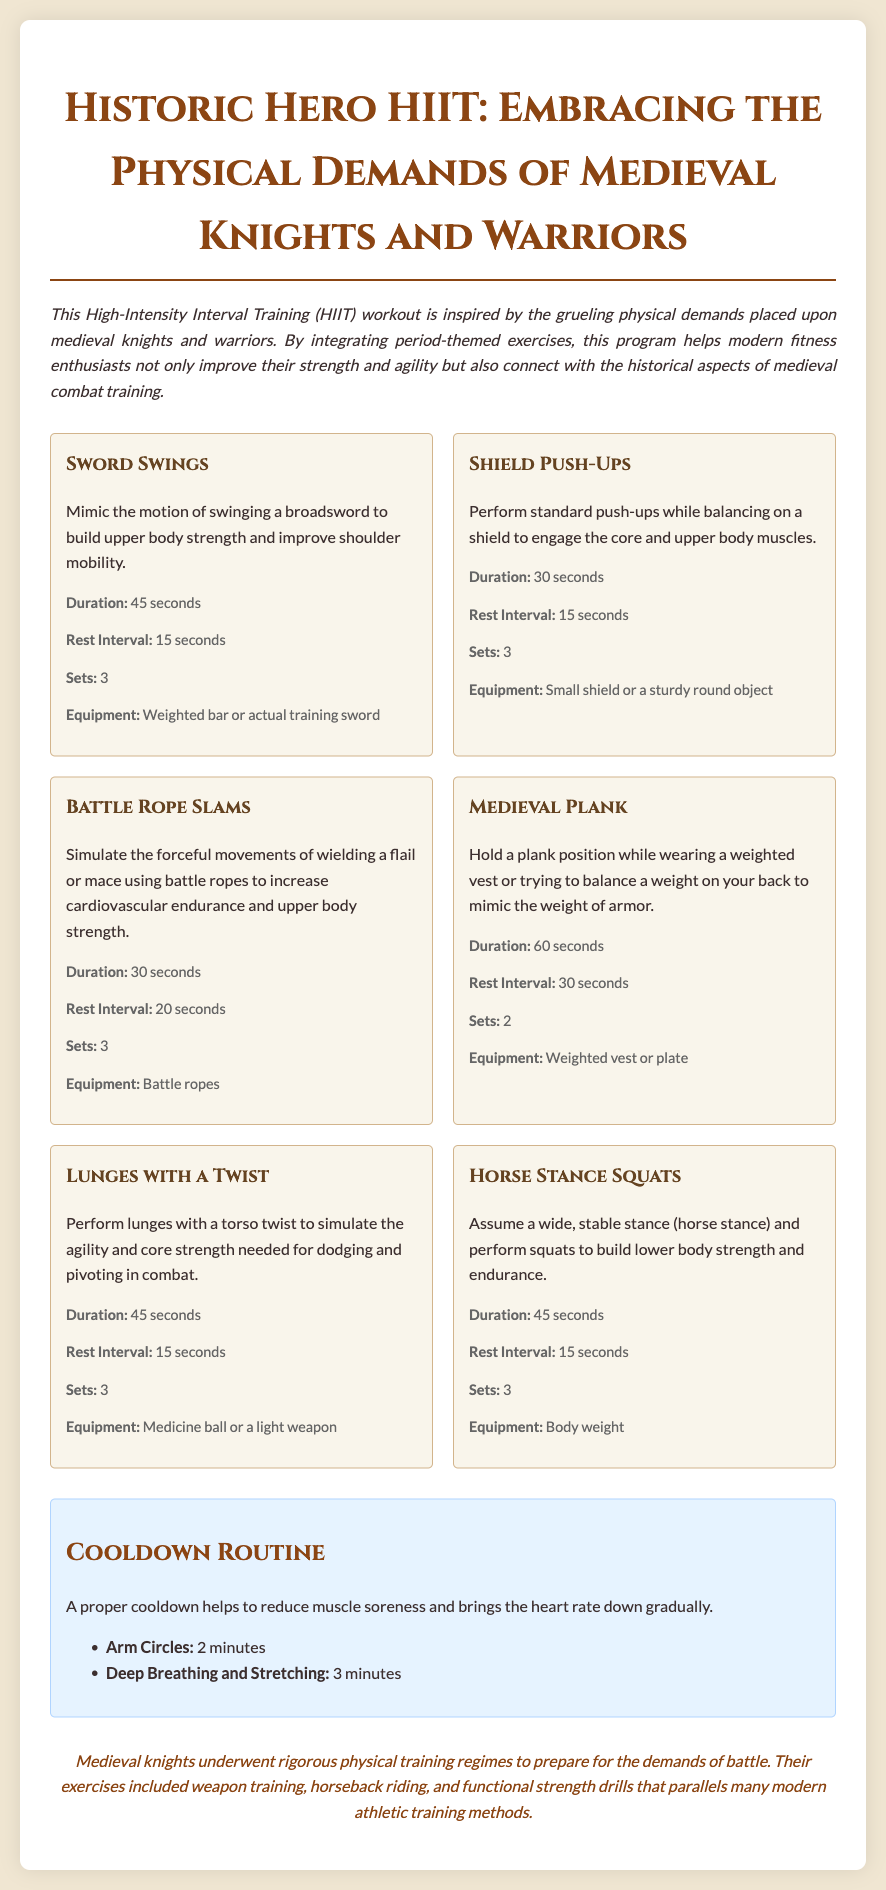What is the intended workout format of the plan? The document outlines a High-Intensity Interval Training (HIIT) workout plan, which involves alternating between periods of intense exercise and rest.
Answer: HIIT How long should the cooldown routine take? The cooldown routine includes specific time recommendations for exercises, totaling 5 minutes.
Answer: 5 minutes What exercise simulates the motion of swinging a sword? The document lists "Sword Swings" as the exercise that mimics this motion to build upper body strength.
Answer: Sword Swings How many sets of Battle Rope Slams are prescribed? The workout plan specifies the number of sets for each exercise, and for Battle Rope Slams, it is 3 sets.
Answer: 3 What equipment is needed for Shield Push-Ups? The document indicates that a small shield or a sturdy round object is recommended for this exercise.
Answer: Small shield or a sturdy round object What is the duration of the Medieval Plank exercise? The workout plan stipulates that the Medieval Plank should be held for 60 seconds.
Answer: 60 seconds Which exercise incorporates a torso twist? The "Lunges with a Twist" exercise includes torso twisting to enhance agility and core strength.
Answer: Lunges with a Twist How many seconds of rest are recommended after performing Horse Stance Squats? The rest interval after Horse Stance Squats is specified as 15 seconds in the document.
Answer: 15 seconds What historical aspect does the document connect to the workout? The document discusses the rigorous physical training regimes of medieval knights and warriors and parallels it with modern athletic training methods.
Answer: Physical training regimes of medieval knights 